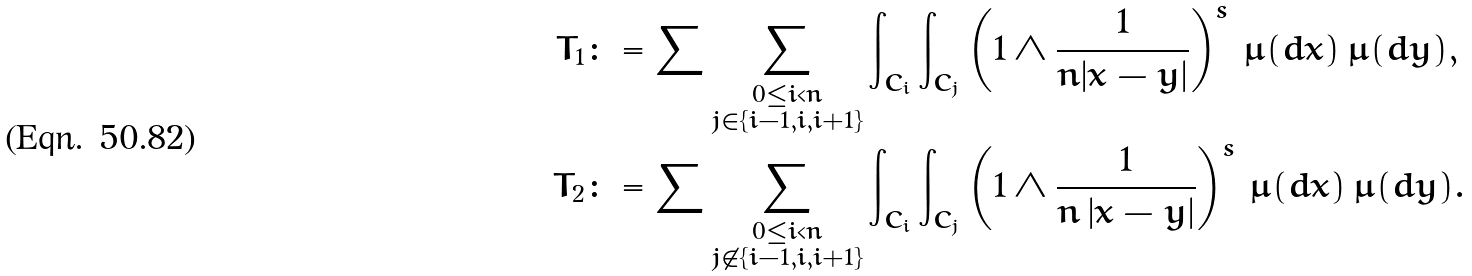Convert formula to latex. <formula><loc_0><loc_0><loc_500><loc_500>T _ { 1 } & \colon = \sum \sum _ { \substack { 0 \leq i < n \\ j \in \{ i - 1 , i , i + 1 \} } } \int _ { C _ { i } } \int _ { C _ { j } } \left ( 1 \wedge \frac { 1 } { n | x - y | } \right ) ^ { s } \, \mu ( d x ) \, \mu ( d y ) , \\ T _ { 2 } & \colon = \sum \sum _ { \substack { 0 \leq i < n \\ j \not \in \{ i - 1 , i , i + 1 \} } } \int _ { C _ { i } } \int _ { C _ { j } } \left ( 1 \wedge \frac { 1 } { n \, | x - y | } \right ) ^ { s } \, \mu ( d x ) \, \mu ( d y ) .</formula> 